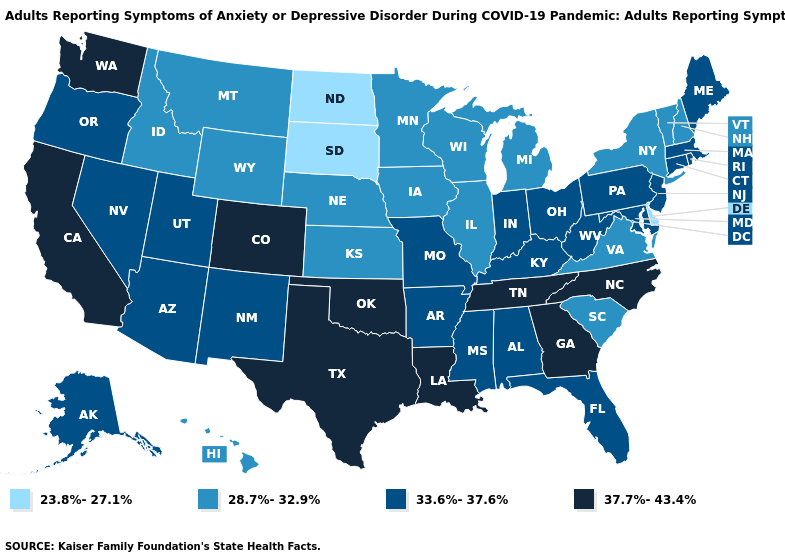Name the states that have a value in the range 37.7%-43.4%?
Be succinct. California, Colorado, Georgia, Louisiana, North Carolina, Oklahoma, Tennessee, Texas, Washington. Does Illinois have the lowest value in the MidWest?
Quick response, please. No. Name the states that have a value in the range 23.8%-27.1%?
Give a very brief answer. Delaware, North Dakota, South Dakota. What is the value of New Jersey?
Quick response, please. 33.6%-37.6%. Among the states that border West Virginia , does Virginia have the highest value?
Give a very brief answer. No. Name the states that have a value in the range 33.6%-37.6%?
Be succinct. Alabama, Alaska, Arizona, Arkansas, Connecticut, Florida, Indiana, Kentucky, Maine, Maryland, Massachusetts, Mississippi, Missouri, Nevada, New Jersey, New Mexico, Ohio, Oregon, Pennsylvania, Rhode Island, Utah, West Virginia. What is the value of New Hampshire?
Write a very short answer. 28.7%-32.9%. Which states have the lowest value in the USA?
Be succinct. Delaware, North Dakota, South Dakota. Does Illinois have a higher value than North Dakota?
Give a very brief answer. Yes. What is the highest value in states that border Rhode Island?
Answer briefly. 33.6%-37.6%. Does Vermont have the highest value in the USA?
Give a very brief answer. No. Name the states that have a value in the range 23.8%-27.1%?
Write a very short answer. Delaware, North Dakota, South Dakota. What is the highest value in states that border Alabama?
Keep it brief. 37.7%-43.4%. Does the map have missing data?
Give a very brief answer. No. Does Oklahoma have the highest value in the USA?
Short answer required. Yes. 